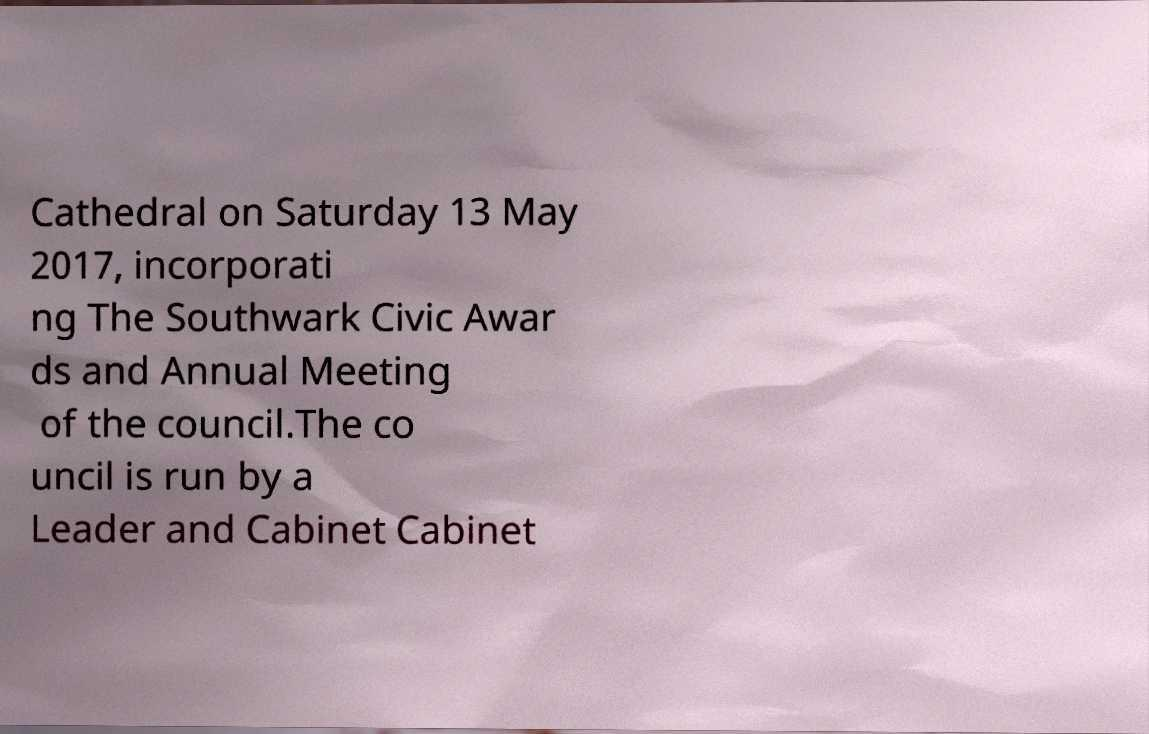For documentation purposes, I need the text within this image transcribed. Could you provide that? Cathedral on Saturday 13 May 2017, incorporati ng The Southwark Civic Awar ds and Annual Meeting of the council.The co uncil is run by a Leader and Cabinet Cabinet 